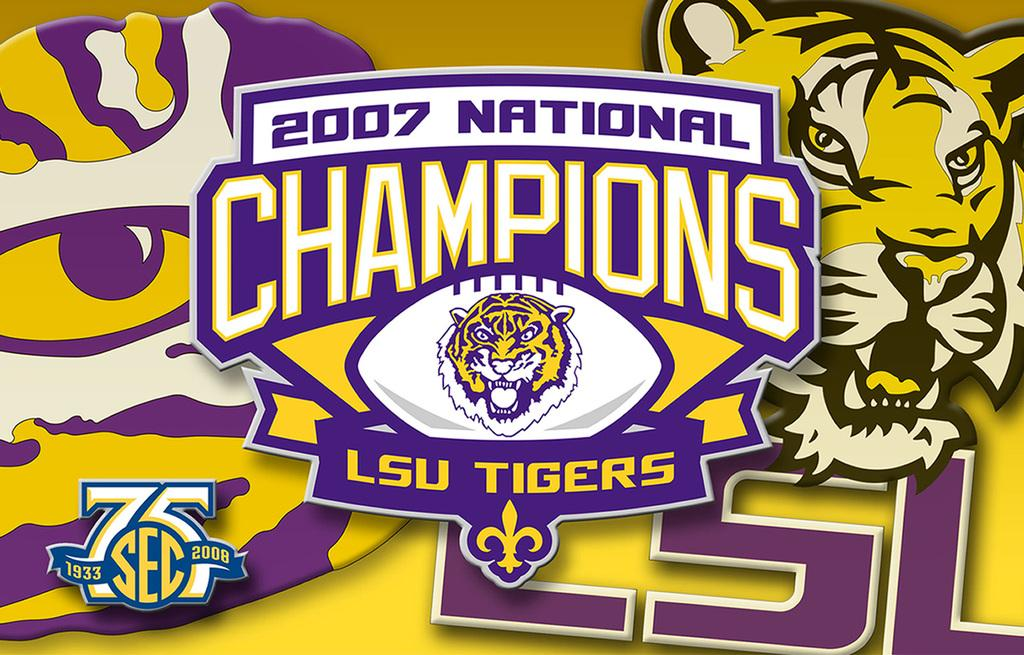What is written on the image? The image has "2007 national champions" written on it. What can be seen behind the main text in the image? There are other pictures visible behind it. Can you see a kitten cooking on the earth in the image? No, there is no kitten or cooking scene involving the earth in the image. 